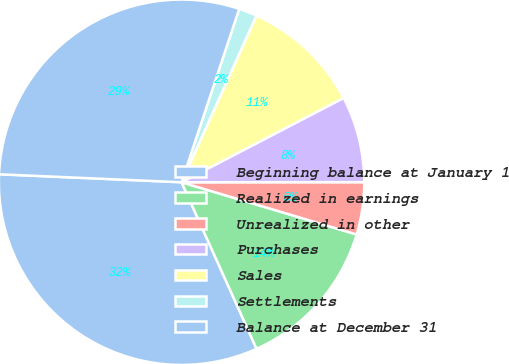<chart> <loc_0><loc_0><loc_500><loc_500><pie_chart><fcel>Beginning balance at January 1<fcel>Realized in earnings<fcel>Unrealized in other<fcel>Purchases<fcel>Sales<fcel>Settlements<fcel>Balance at December 31<nl><fcel>32.43%<fcel>13.65%<fcel>4.62%<fcel>7.63%<fcel>10.64%<fcel>1.61%<fcel>29.41%<nl></chart> 